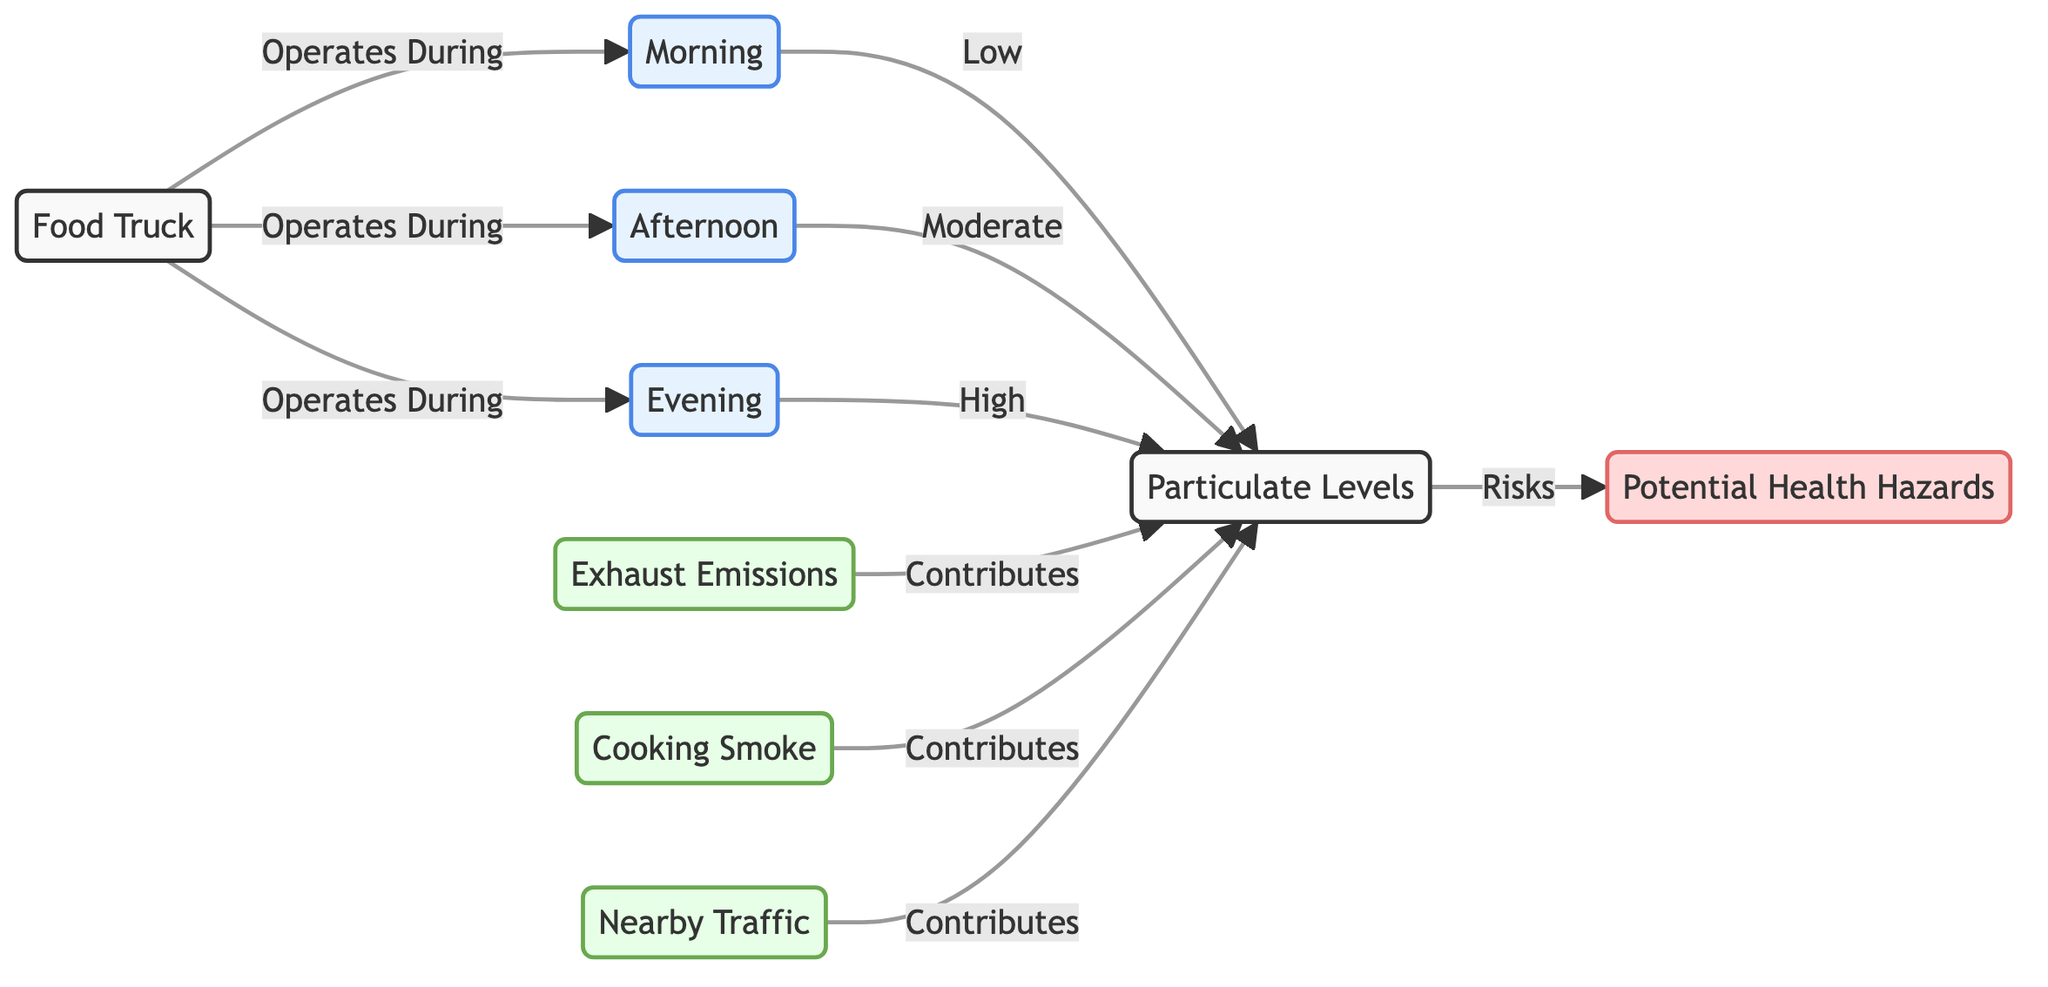What are the particulate levels in the morning? The diagram states that the particulate levels during the morning are labeled as "Low." This is directly indicated in the flow from the morning node to the particulate levels node.
Answer: Low What time of day do food trucks operate? The diagram shows that food trucks operate during three specific times of the day: morning, afternoon, and evening. This can be seen from the connections leading from the food truck node to each of the time nodes.
Answer: Morning, Afternoon, Evening What is the level of particulate matter in the evening? According to the diagram, the particulate levels in the evening are labeled as "High." This is detailed in the flow from the evening node to the particulate levels node.
Answer: High Identify one source of particulate matter. The diagram lists several sources contributing to particulate matter. One example provided is "Exhaust Emissions," which is indicated as a source node contributing to the particulate levels.
Answer: Exhaust Emissions How do cooking smoke and traffic contribute to health hazards? The diagram indicates that both cooking smoke and nearby traffic contribute to particulate levels, which then lead to health hazards. The reasoning involves tracing the flow from the sources (cooking smoke and traffic) to the particulate levels, and then to the health hazards node, showing the connection between them.
Answer: They contribute to particulate levels, leading to health hazards What is the relationship between afternoon and particulate levels? In the diagram, there is a direct connection from the afternoon node to the particulate levels node indicating that the particulate levels during the afternoon are categorized as "Moderate." Thus, the relationship is that the afternoon contributes to moderate particulate levels.
Answer: Moderate Which time of day has the highest airborne particulate matter? The diagram clearly indicates that the evening has the highest particulate levels, as shown by the connection from the evening node to the particulate levels node labeled "High."
Answer: Evening Count the number of sources contributing to particulate levels. The diagram shows three source nodes: exhaust emissions, cooking smoke, and nearby traffic. Therefore, to find the count, we tally these nodes.
Answer: 3 